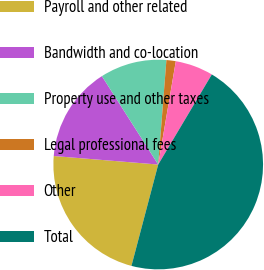Convert chart to OTSL. <chart><loc_0><loc_0><loc_500><loc_500><pie_chart><fcel>Payroll and other related<fcel>Bandwidth and co-location<fcel>Property use and other taxes<fcel>Legal professional fees<fcel>Other<fcel>Total<nl><fcel>22.19%<fcel>14.68%<fcel>10.27%<fcel>1.44%<fcel>5.86%<fcel>45.57%<nl></chart> 